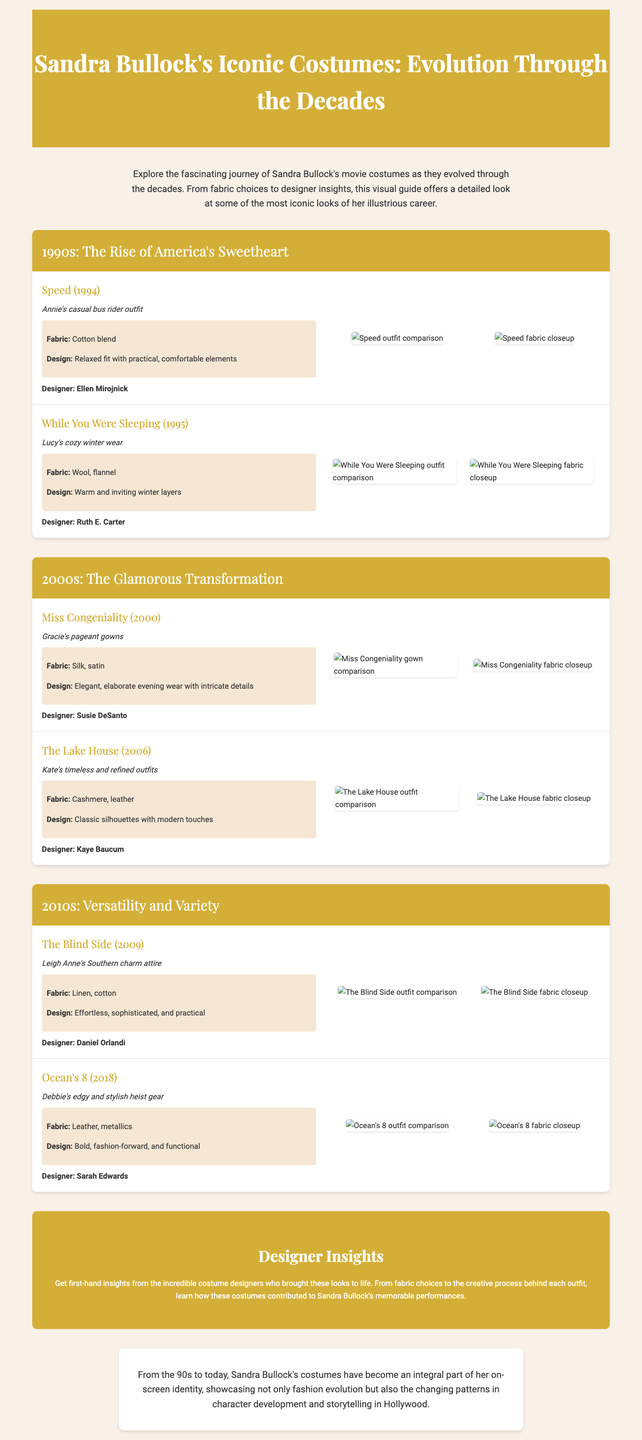what costume was worn in Speed (1994)? The costume worn in Speed is Annie's casual bus rider outfit.
Answer: Annie's casual bus rider outfit who designed the costume for While You Were Sleeping (1995)? The designer for the costume in While You Were Sleeping is Ruth E. Carter.
Answer: Ruth E. Carter what fabric was used for Gracie's pageant gowns in Miss Congeniality (2000)? The fabric used for Gracie's pageant gowns is silk and satin.
Answer: Silk, satin which decade showcases Sandra Bullock's costumes as "The Glamorous Transformation"? The 2000s showcases Sandra Bullock's costumes as "The Glamorous Transformation".
Answer: 2000s describe the design of Kate's outfits in The Lake House (2006). The design of Kate's outfits in The Lake House is classic silhouettes with modern touches.
Answer: Classic silhouettes with modern touches what is the main theme of the designer insights section? The main theme of the designer insights section is the creative process behind each outfit.
Answer: Creative process behind each outfit how many movies are mentioned in the 2010s section? The 2010s section mentions two movies.
Answer: Two movies what costume detail is associated with Debbie's edgy outfit in Ocean's 8 (2018)? The costume detail associated with Debbie's outfit is bold, fashion-forward, and functional design.
Answer: Bold, fashion-forward, and functional what type of fabric is mentioned for Leigh Anne's attire in The Blind Side (2009)? The type of fabric mentioned for Leigh Anne's attire is linen and cotton.
Answer: Linen, cotton 